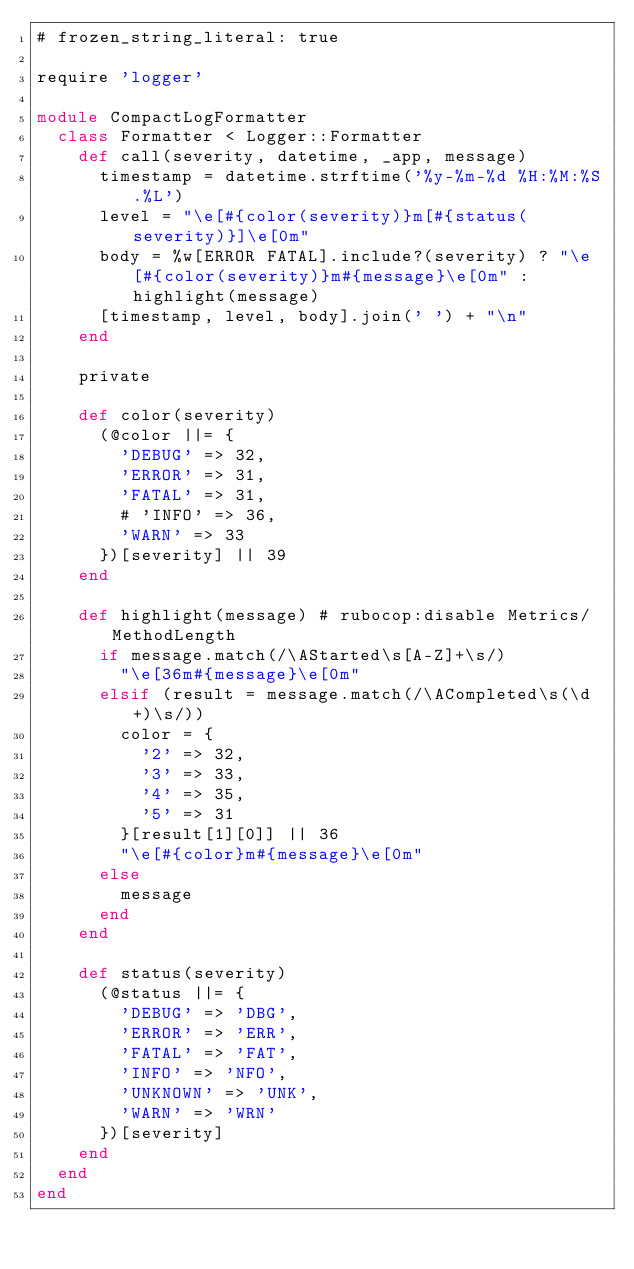Convert code to text. <code><loc_0><loc_0><loc_500><loc_500><_Ruby_># frozen_string_literal: true

require 'logger'

module CompactLogFormatter
  class Formatter < Logger::Formatter
    def call(severity, datetime, _app, message)
      timestamp = datetime.strftime('%y-%m-%d %H:%M:%S.%L')
      level = "\e[#{color(severity)}m[#{status(severity)}]\e[0m"
      body = %w[ERROR FATAL].include?(severity) ? "\e[#{color(severity)}m#{message}\e[0m" : highlight(message)
      [timestamp, level, body].join(' ') + "\n"
    end

    private

    def color(severity)
      (@color ||= {
        'DEBUG' => 32,
        'ERROR' => 31,
        'FATAL' => 31,
        # 'INFO' => 36,
        'WARN' => 33
      })[severity] || 39
    end

    def highlight(message) # rubocop:disable Metrics/MethodLength
      if message.match(/\AStarted\s[A-Z]+\s/)
        "\e[36m#{message}\e[0m"
      elsif (result = message.match(/\ACompleted\s(\d+)\s/))
        color = {
          '2' => 32,
          '3' => 33,
          '4' => 35,
          '5' => 31
        }[result[1][0]] || 36
        "\e[#{color}m#{message}\e[0m"
      else
        message
      end
    end

    def status(severity)
      (@status ||= {
        'DEBUG' => 'DBG',
        'ERROR' => 'ERR',
        'FATAL' => 'FAT',
        'INFO' => 'NFO',
        'UNKNOWN' => 'UNK',
        'WARN' => 'WRN'
      })[severity]
    end
  end
end
</code> 